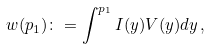Convert formula to latex. <formula><loc_0><loc_0><loc_500><loc_500>w ( p _ { 1 } ) \colon = \int ^ { p _ { 1 } } I ( y ) V ( y ) d y \, ,</formula> 